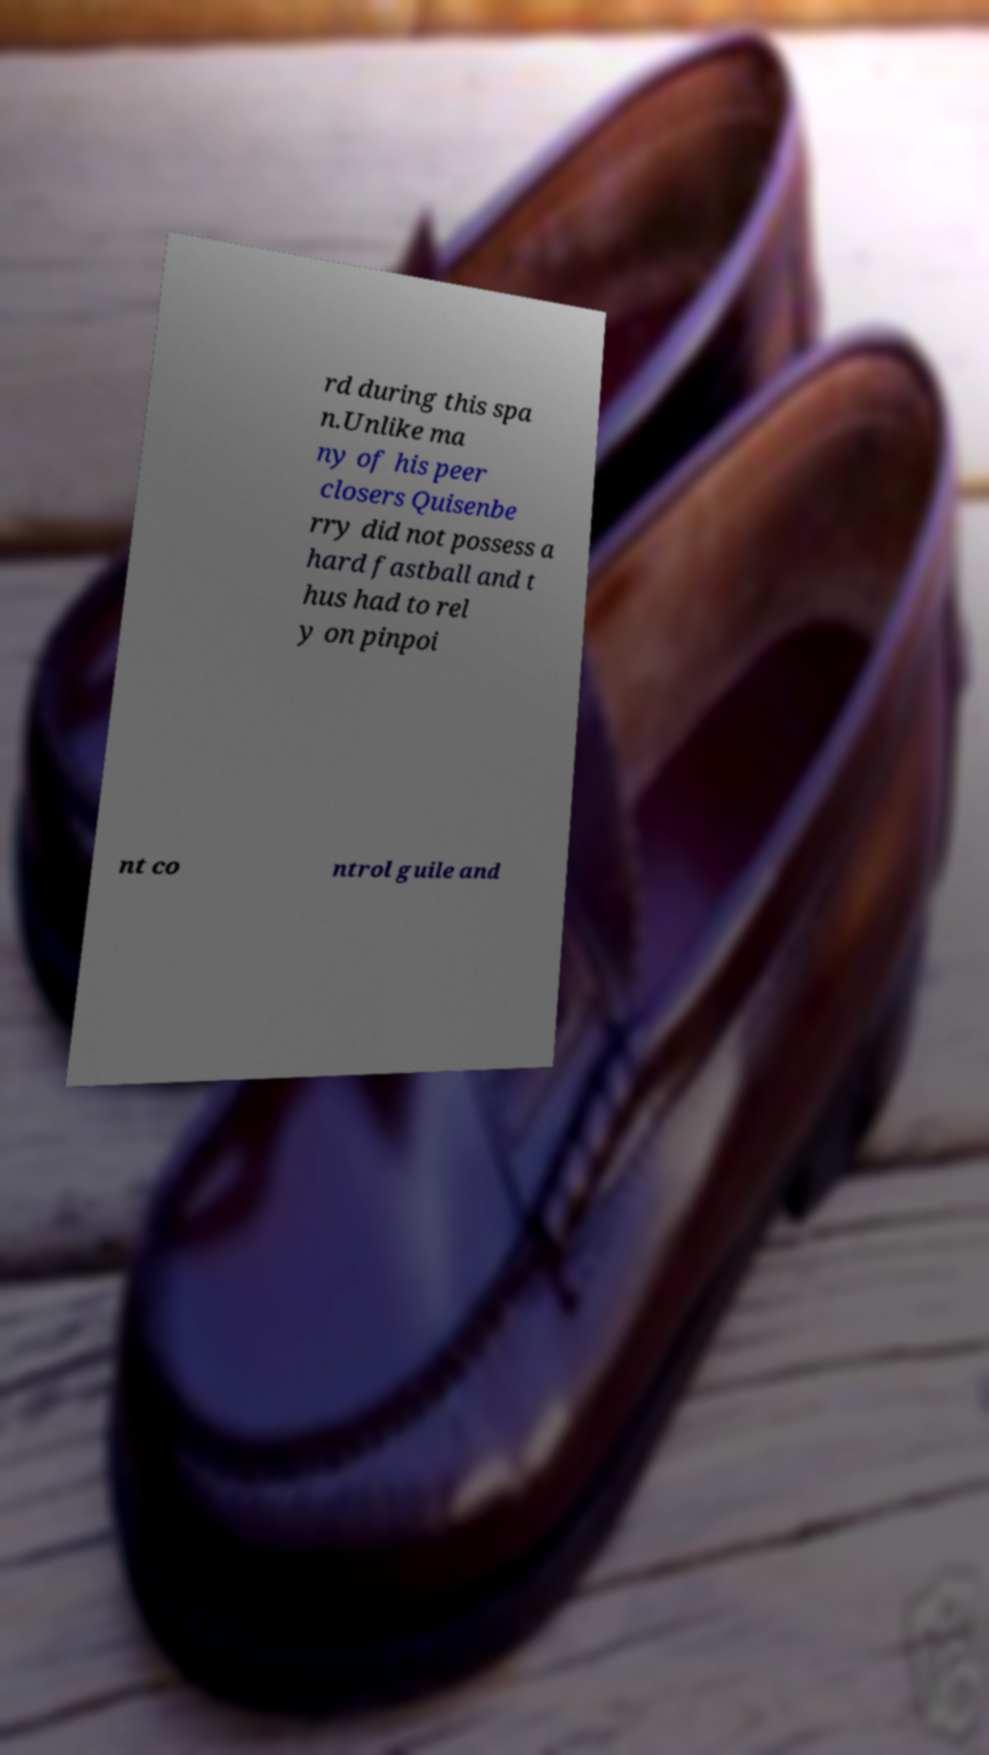For documentation purposes, I need the text within this image transcribed. Could you provide that? rd during this spa n.Unlike ma ny of his peer closers Quisenbe rry did not possess a hard fastball and t hus had to rel y on pinpoi nt co ntrol guile and 